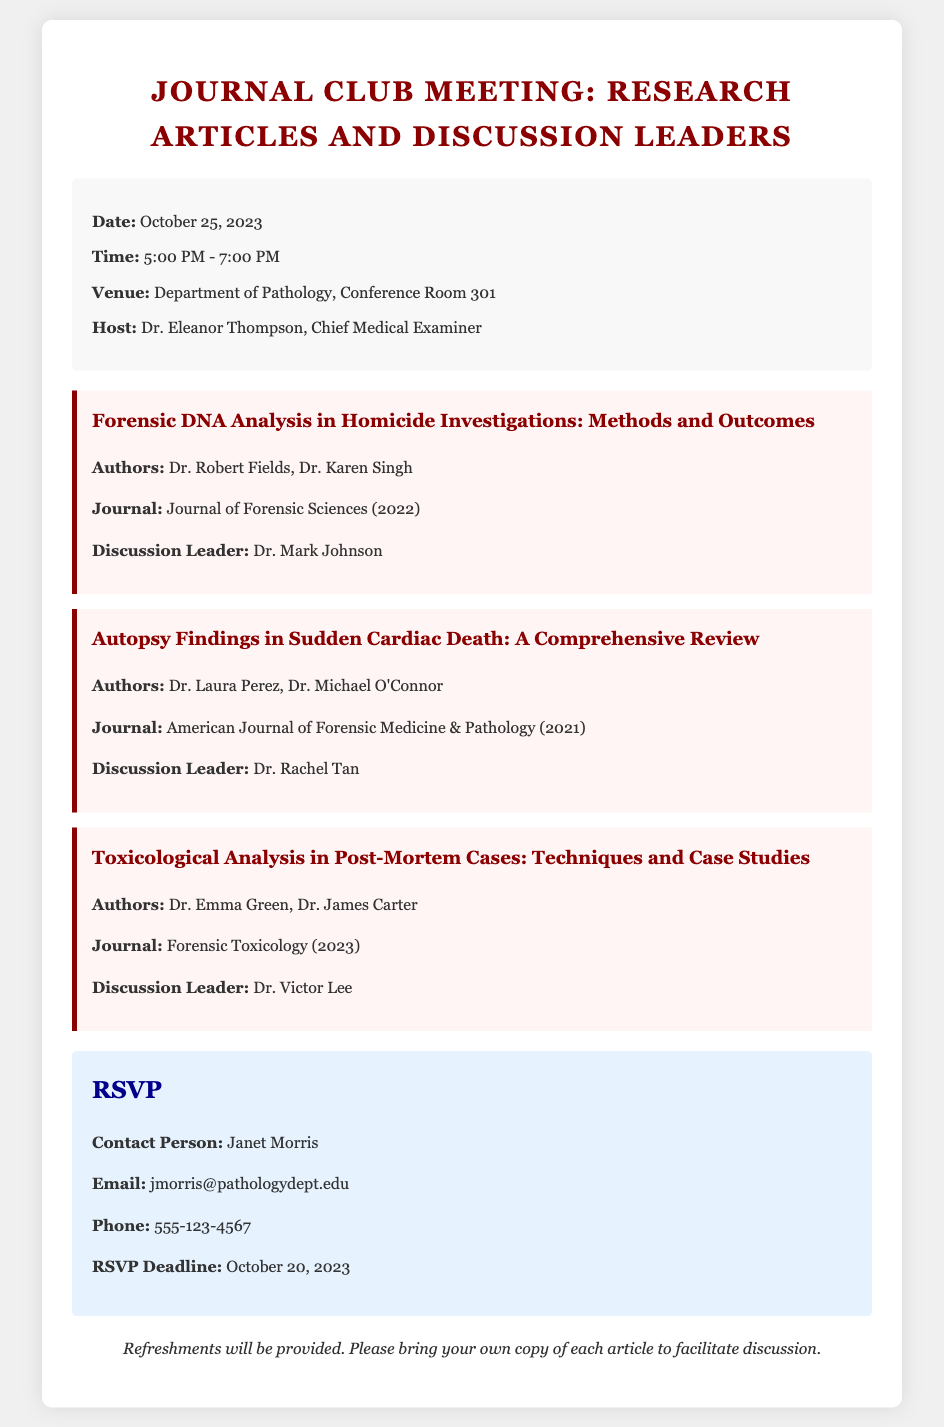what is the date of the Journal Club Meeting? The date of the event is mentioned in the event details section of the document.
Answer: October 25, 2023 who is the host of the meeting? The host's name is provided in the event details section of the document.
Answer: Dr. Eleanor Thompson what time does the meeting start? The starting time is listed in the event details of the document.
Answer: 5:00 PM how many discussion topics are listed? The number of topics can be counted in the topics section of the document.
Answer: Three who leads the discussion on the first topic? The discussion leader's name for the first topic is specified in the topic section.
Answer: Dr. Mark Johnson what is the RSVP deadline? The deadline for RSVPs is explicitly mentioned in the RSVP section of the document.
Answer: October 20, 2023 which journal published the second article? The journal name is listed with the second article in the topics section of the document.
Answer: American Journal of Forensic Medicine & Pathology who is the contact person for RSVPs? The name of the contact person is provided in the RSVP section of the document.
Answer: Janet Morris what will be provided during the meeting? The document mentions something that will be available for attendees during the meeting.
Answer: Refreshments 